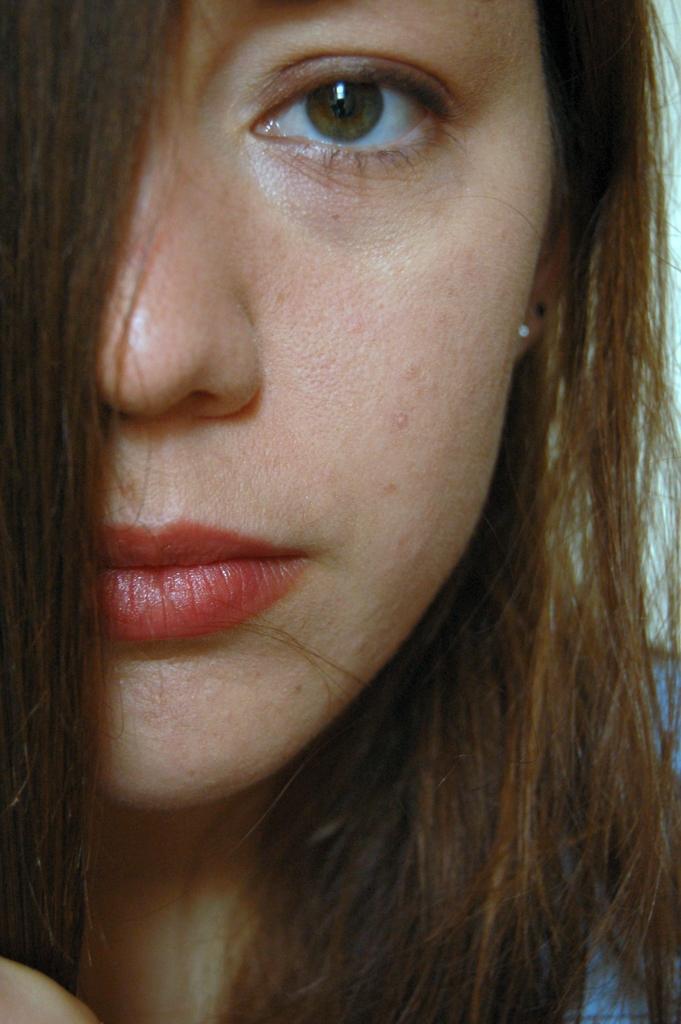Can you describe this image briefly? This is the zoom-in picture of a face of a woman. 